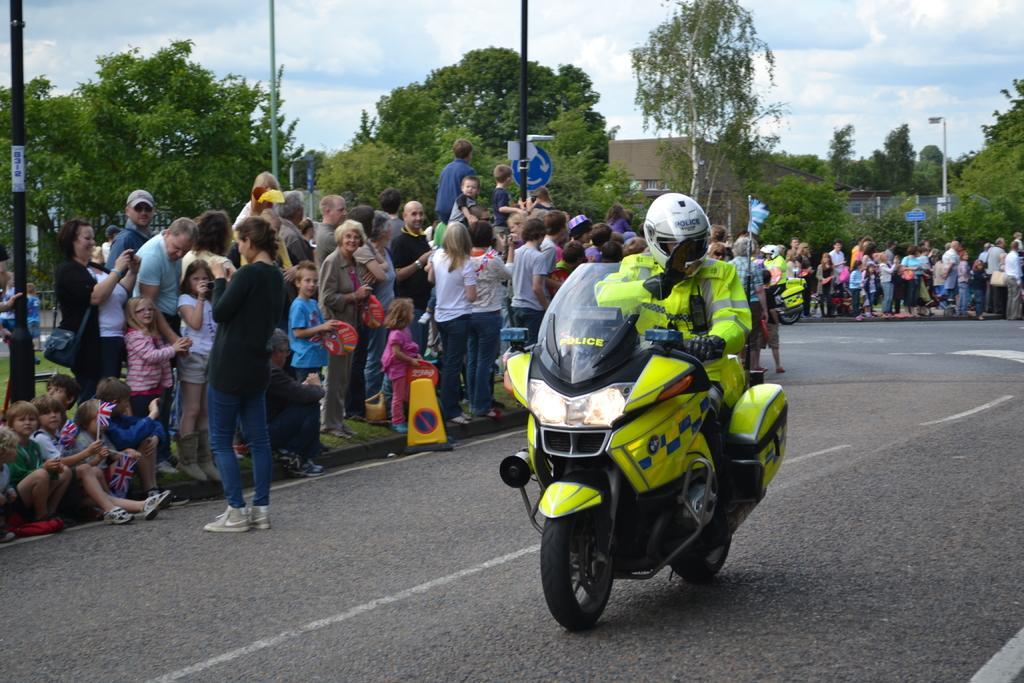Can you describe this image briefly? Here I can see a person wearing jacket, helmet on the head and the riding the bike on the road. On both sides of the road there are many people standing and looking at this person. In the background there are some buildings, trees and poles. On the top of the image I can see the sky. 